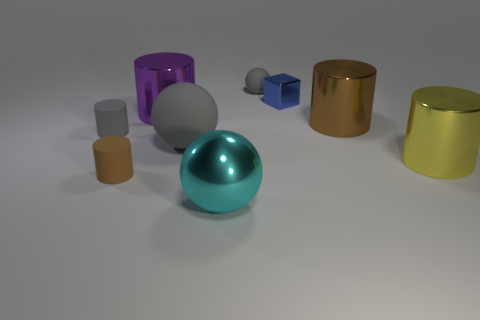The other big thing that is the same shape as the large rubber thing is what color? cyan 